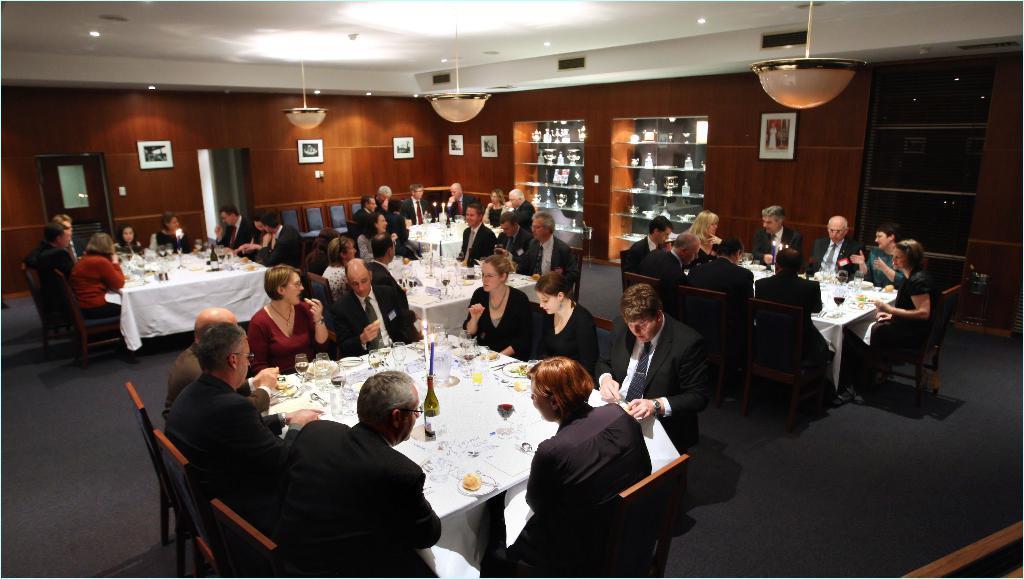How would you summarize this image in a sentence or two? In this image there are group of persons who are sitting around the table and having some drinks and food. 